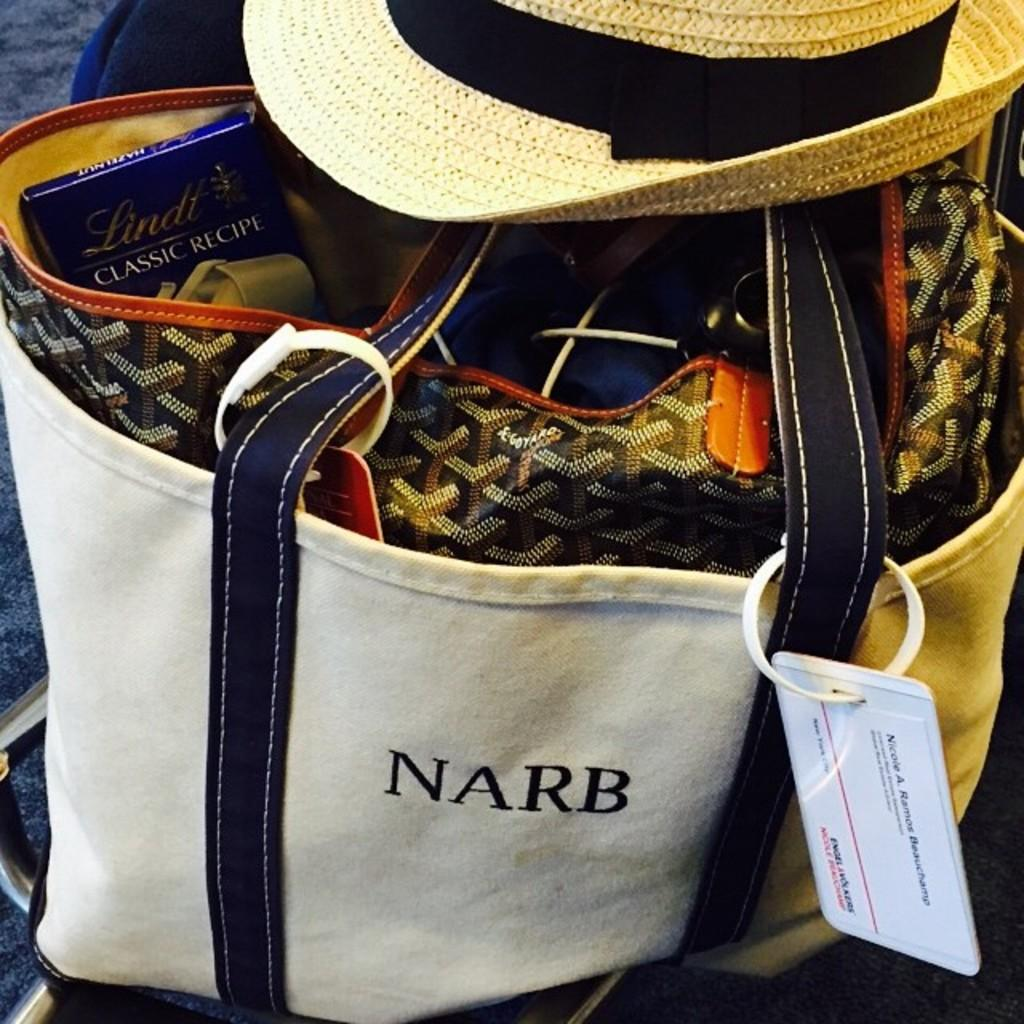What type of accessory is visible in the image? There is a handbag in the image. Is there anything placed on the handbag? Yes, there is a hat on the handbag. Can you see any jelly in the image? No, there is no jelly present in the image. 